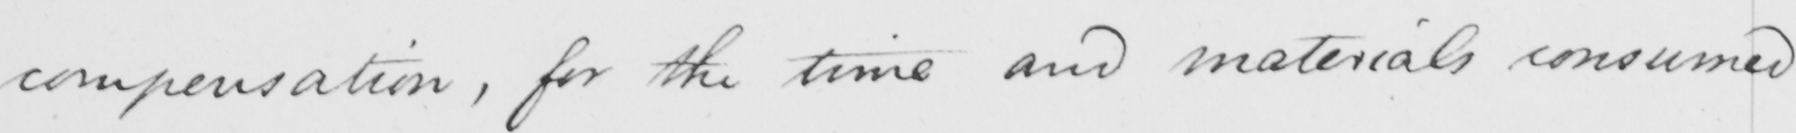What is written in this line of handwriting? compensation , for the time and materials consumed 